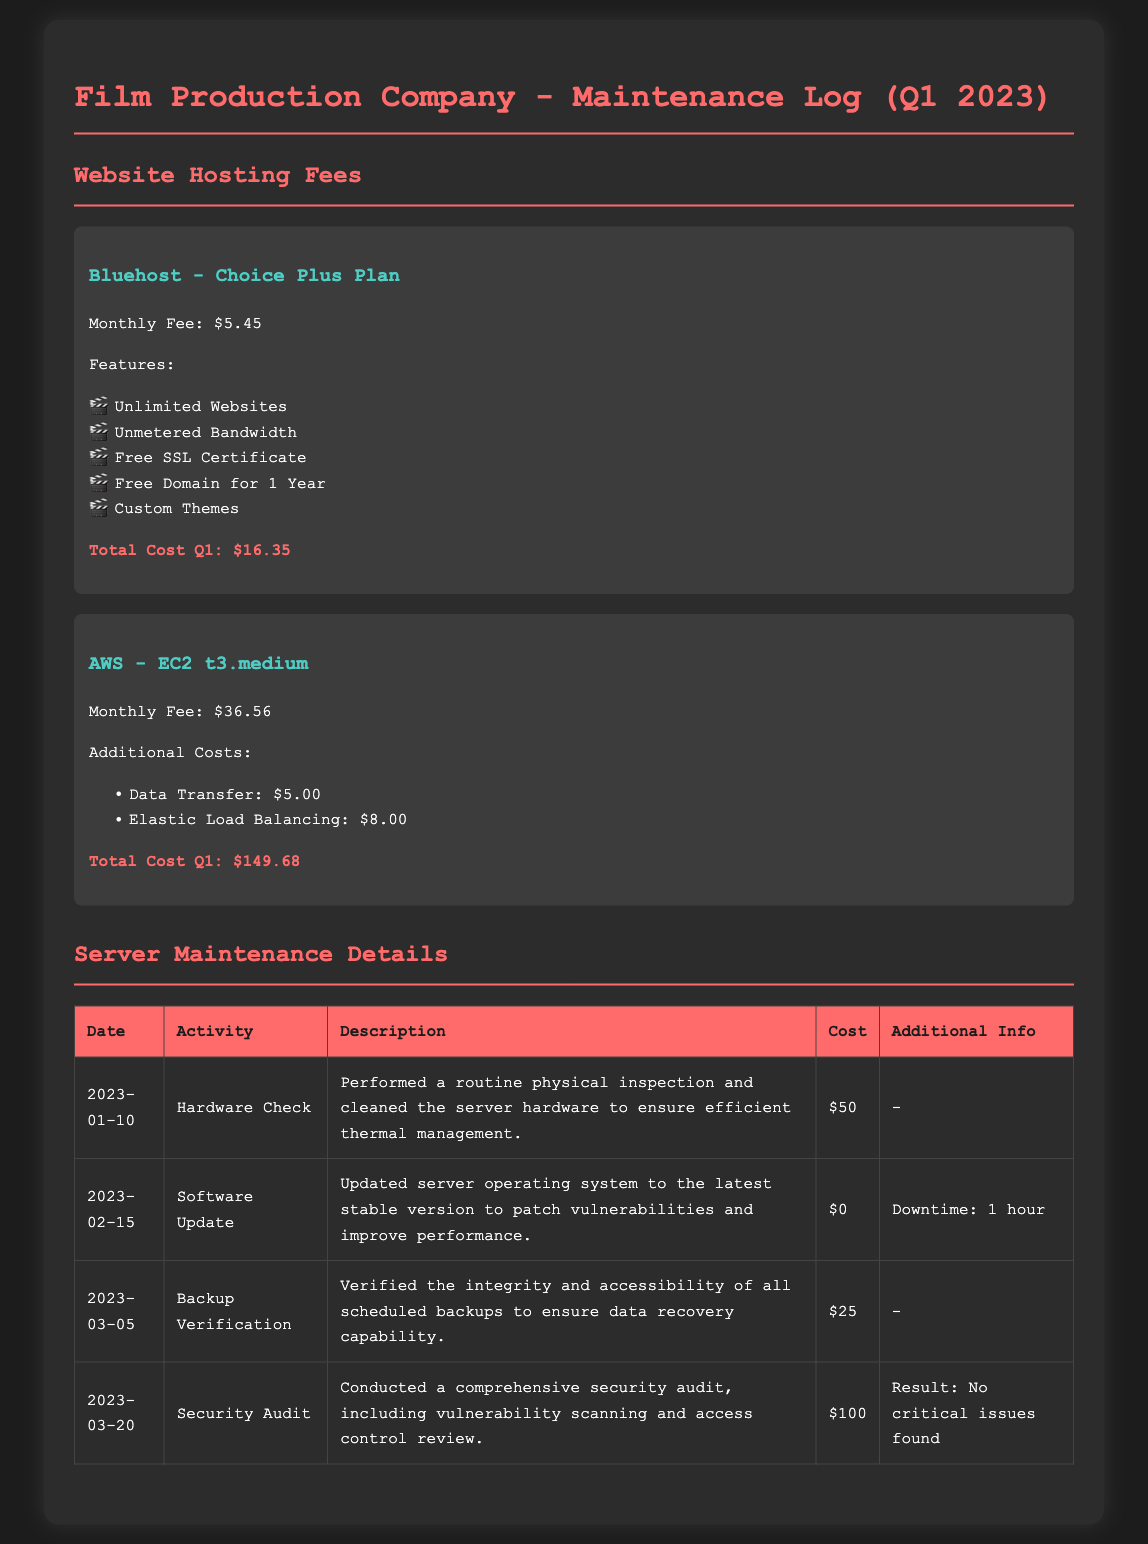What is the monthly fee for Bluehost? The monthly fee for Bluehost is listed in the document as $5.45.
Answer: $5.45 What features does the Bluehost plan include? The features of the Bluehost plan are found in the document, which include Unlimited Websites, Unmetered Bandwidth, Free SSL Certificate, Free Domain for 1 Year, and Custom Themes.
Answer: Unlimited Websites, Unmetered Bandwidth, Free SSL Certificate, Free Domain for 1 Year, Custom Themes What is the total cost for AWS in Q1 2023? The total cost for AWS in Q1 is the amount stated in the document, which sums up to $149.68.
Answer: $149.68 How much did the Security Audit cost? The cost of the Security Audit is mentioned in the table, which is $100.
Answer: $100 What was the date of the Software Update? The date for the Software Update is detailed in the table as 2023-02-15.
Answer: 2023-02-15 What activity was performed on 2023-01-10? The activity on this date is mentioned in the document as Hardware Check.
Answer: Hardware Check How many hours of downtime were experienced during the Software Update? The downtime due to the Software Update is listed in the additional info as 1 hour.
Answer: 1 hour What was the result of the Security Audit? The result of the Security Audit is described in the additional info as "No critical issues found."
Answer: No critical issues found 